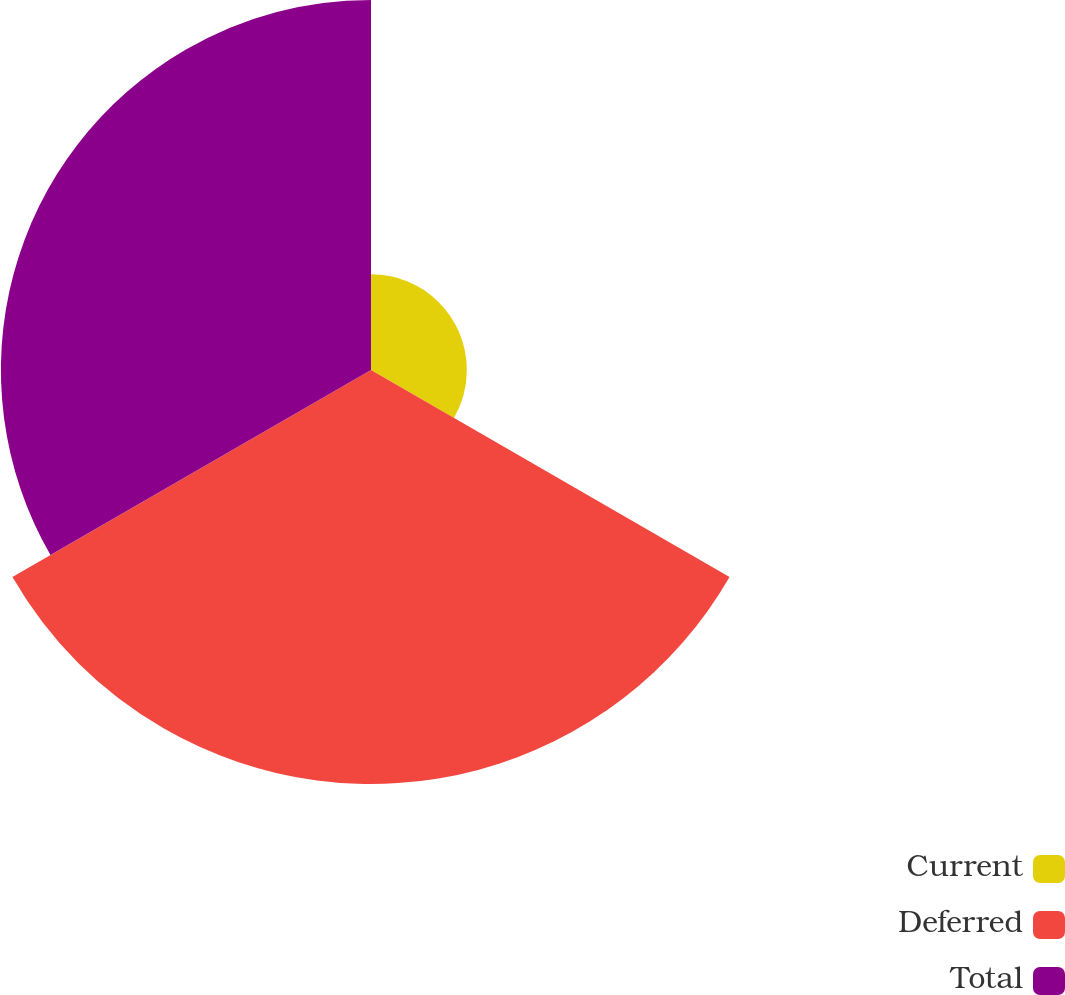Convert chart. <chart><loc_0><loc_0><loc_500><loc_500><pie_chart><fcel>Current<fcel>Deferred<fcel>Total<nl><fcel>10.89%<fcel>47.05%<fcel>42.06%<nl></chart> 